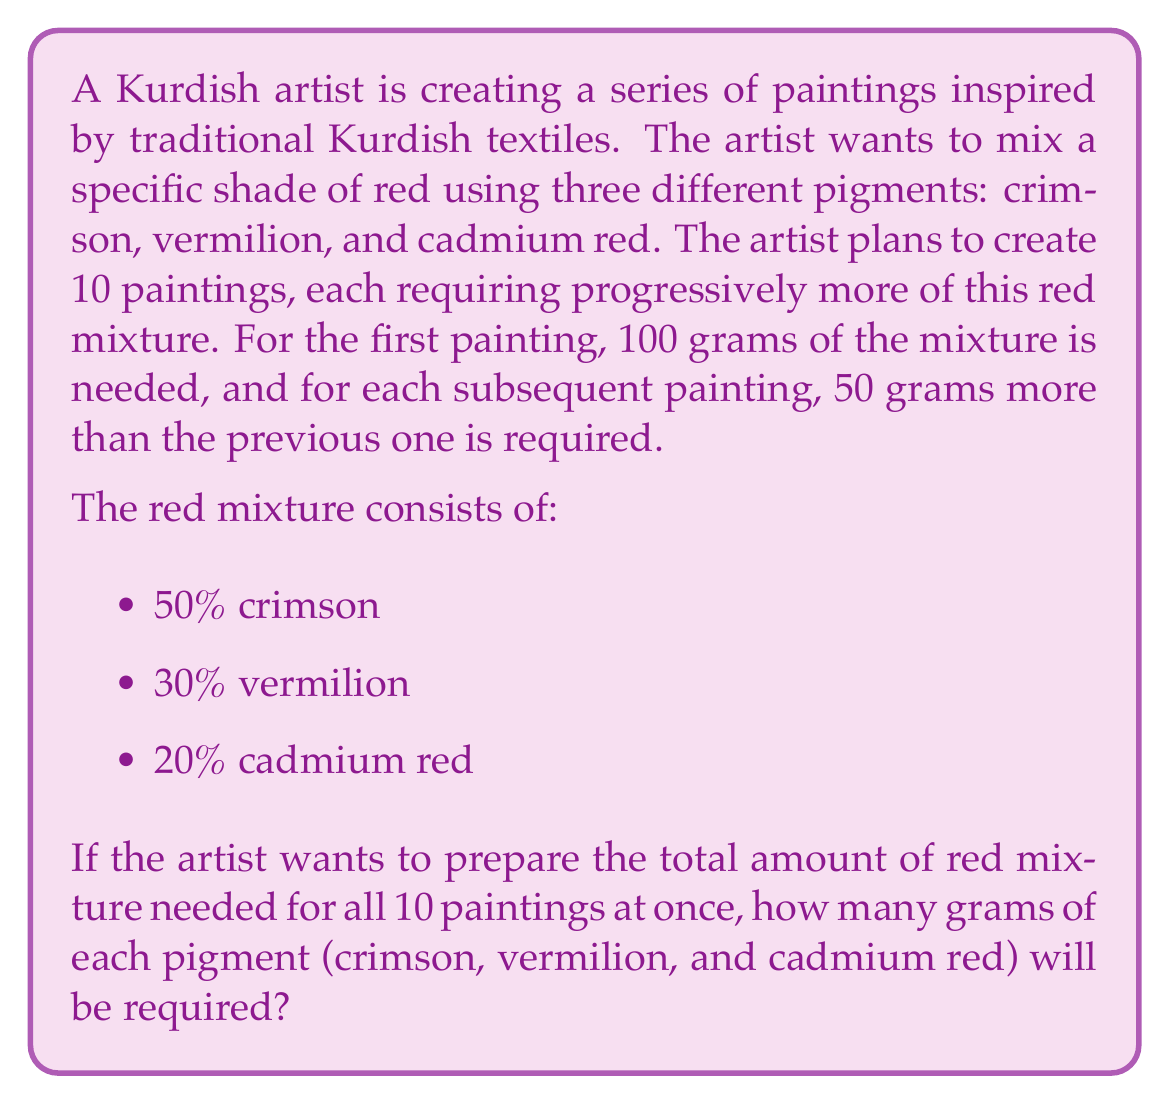Could you help me with this problem? To solve this problem, we need to follow these steps:

1. Calculate the total amount of red mixture needed for all 10 paintings.
2. Determine the amount of each pigment based on their percentages in the mixture.

Step 1: Calculate the total amount of red mixture

The amount of mixture for each painting forms an arithmetic sequence with:
- First term: $a_1 = 100$ grams
- Common difference: $d = 50$ grams
- Number of terms: $n = 10$

We can use the arithmetic sequence sum formula:
$$S_n = \frac{n}{2}(a_1 + a_n)$$

Where $a_n$ is the last term, calculated as:
$$a_n = a_1 + (n-1)d = 100 + (10-1)50 = 550$$

Now, let's calculate the sum:
$$S_{10} = \frac{10}{2}(100 + 550) = 5 \times 650 = 3250$$

The total amount of red mixture needed is 3250 grams.

Step 2: Determine the amount of each pigment

Crimson (50%): $0.50 \times 3250 = 1625$ grams
Vermilion (30%): $0.30 \times 3250 = 975$ grams
Cadmium red (20%): $0.20 \times 3250 = 650$ grams
Answer: The artist will need:
Crimson: 1625 grams
Vermilion: 975 grams
Cadmium red: 650 grams 